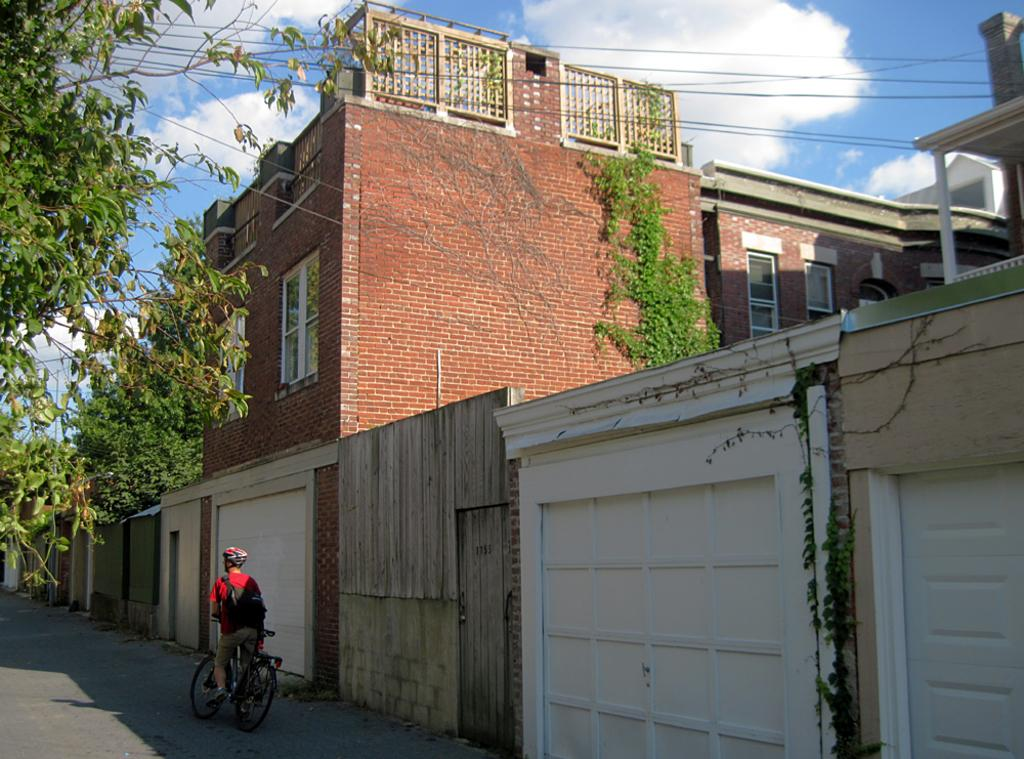What type of structures are present in the image? There are buildings with windows in the image. What natural elements can be seen in the image? There are trees in the image. What is the man wearing in the image? The man is wearing a helmet in the image. What mode of transportation is visible in the image? There is a bicycle on the road in the image. What else can be seen in the image besides the buildings and trees? Wires are visible in the image. What is visible in the background of the image? The sky with clouds is visible in the background of the image. What type of pie is being served at the station in the image? There is no pie or station present in the image. What mineral properties can be observed in the quartz on the road in the image? There is no quartz present on the road in the image. 